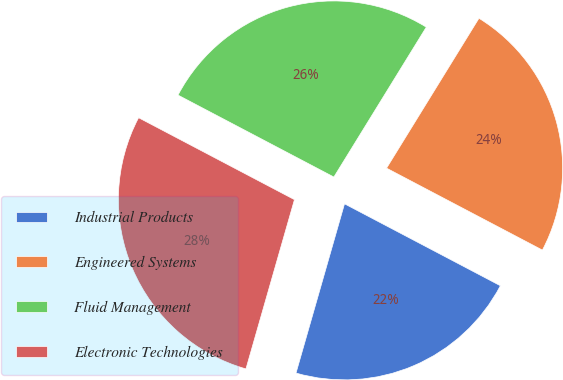<chart> <loc_0><loc_0><loc_500><loc_500><pie_chart><fcel>Industrial Products<fcel>Engineered Systems<fcel>Fluid Management<fcel>Electronic Technologies<nl><fcel>21.74%<fcel>23.91%<fcel>26.09%<fcel>28.26%<nl></chart> 